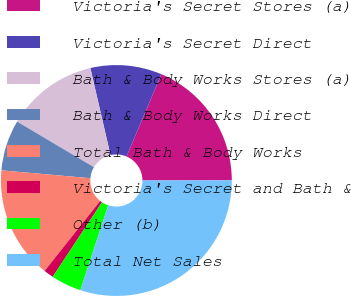Convert chart. <chart><loc_0><loc_0><loc_500><loc_500><pie_chart><fcel>Victoria's Secret Stores (a)<fcel>Victoria's Secret Direct<fcel>Bath & Body Works Stores (a)<fcel>Bath & Body Works Direct<fcel>Total Bath & Body Works<fcel>Victoria's Secret and Bath &<fcel>Other (b)<fcel>Total Net Sales<nl><fcel>18.6%<fcel>9.99%<fcel>12.86%<fcel>7.12%<fcel>15.73%<fcel>1.38%<fcel>4.25%<fcel>30.08%<nl></chart> 